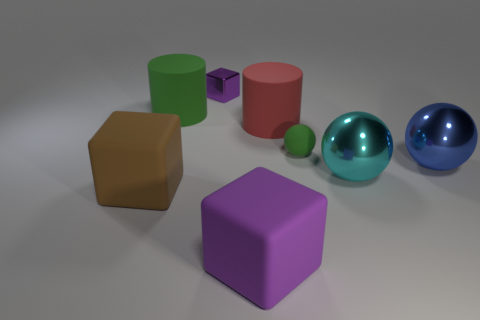Add 2 large green rubber cylinders. How many objects exist? 10 Subtract all purple cubes. How many cubes are left? 1 Subtract 1 blocks. How many blocks are left? 2 Add 4 purple cylinders. How many purple cylinders exist? 4 Subtract all green spheres. How many spheres are left? 2 Subtract 1 green cylinders. How many objects are left? 7 Subtract all cylinders. How many objects are left? 6 Subtract all brown balls. Subtract all green cylinders. How many balls are left? 3 Subtract all green cylinders. How many cyan balls are left? 1 Subtract all metallic cubes. Subtract all red rubber cylinders. How many objects are left? 6 